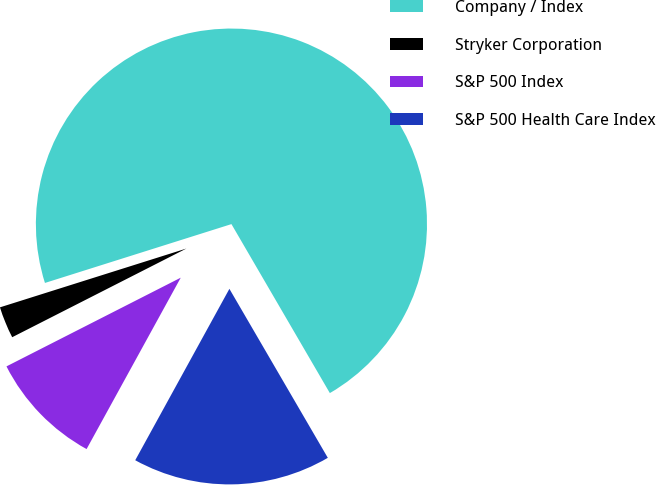Convert chart. <chart><loc_0><loc_0><loc_500><loc_500><pie_chart><fcel>Company / Index<fcel>Stryker Corporation<fcel>S&P 500 Index<fcel>S&P 500 Health Care Index<nl><fcel>71.47%<fcel>2.63%<fcel>9.51%<fcel>16.39%<nl></chart> 